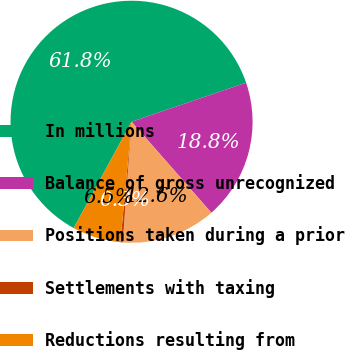Convert chart to OTSL. <chart><loc_0><loc_0><loc_500><loc_500><pie_chart><fcel>In millions<fcel>Balance of gross unrecognized<fcel>Positions taken during a prior<fcel>Settlements with taxing<fcel>Reductions resulting from<nl><fcel>61.85%<fcel>18.77%<fcel>12.62%<fcel>0.31%<fcel>6.46%<nl></chart> 